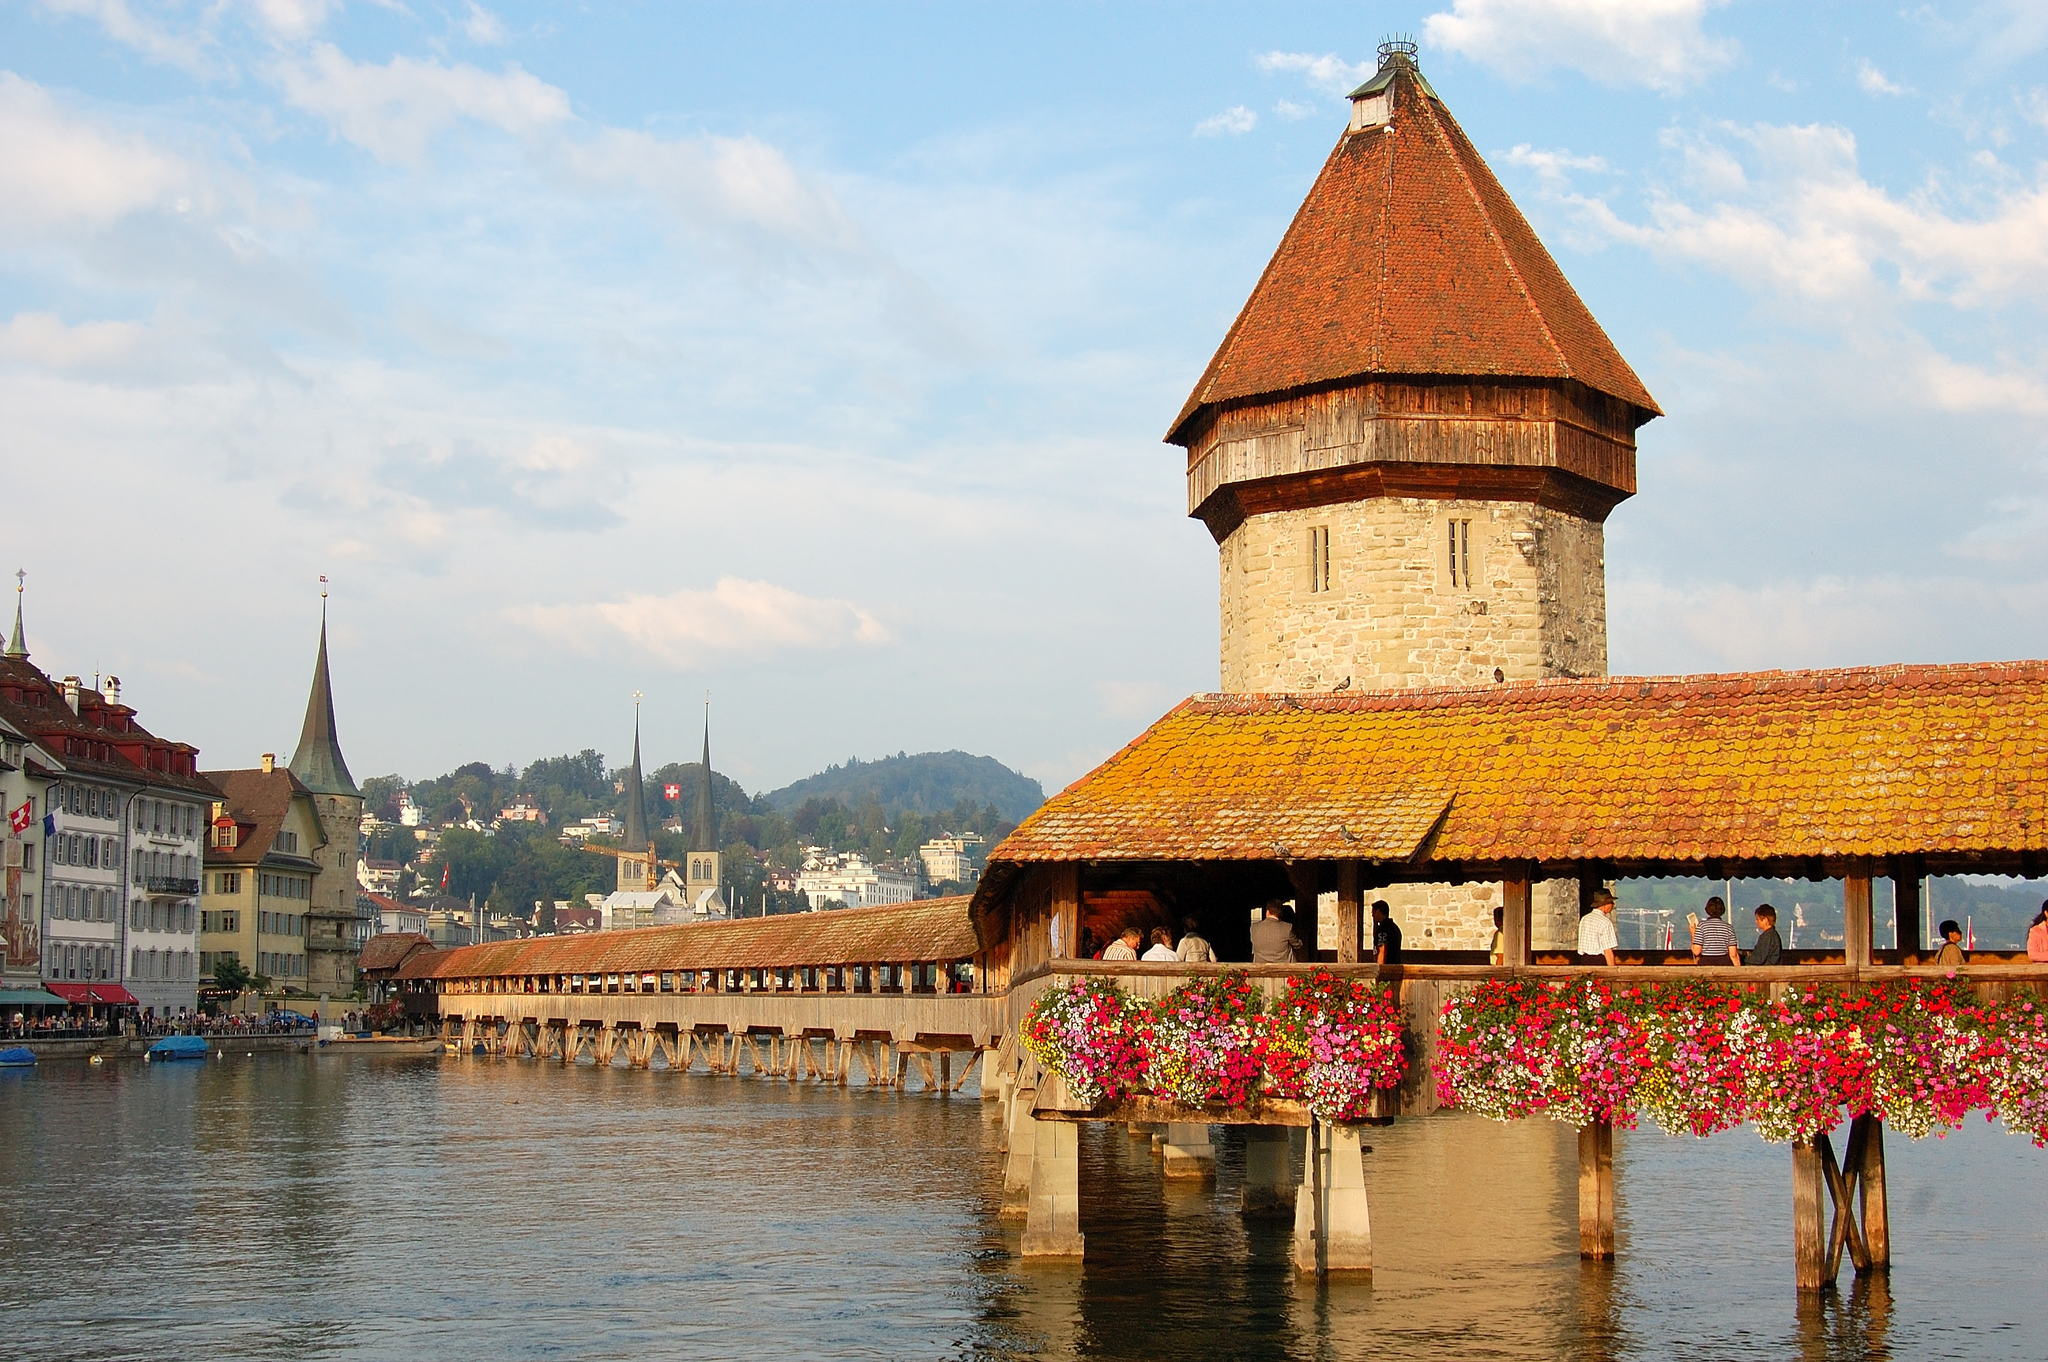Paint a scene where the bridge is a magical portal to another dimension. As twilight descends over Lucerne, the Chapel Bridge begins to shimmer subtly with a mystical glow. The vibrant flowers lining its sides slowly transform into luminous, otherworldly blossoms, pulsing with an enchanting light. Pedestrians crossing the bridge feel an ethereal breeze, and with each step, the wooden planks beneath them begin to radiate a soft, inviting warmth. Upon reaching the stone tower at the center, travelers pass through an invisible veil, emerging on the other side into a realm where the sky is eternally twilight, filled with floating islands and surreal landscapes. This other dimension, bathed in hues of purple and gold, houses ancient floating bridges connecting different worlds, each echoing the timeless elegance of the Chapel Bridge yet immersed in otherworldly wonder. 